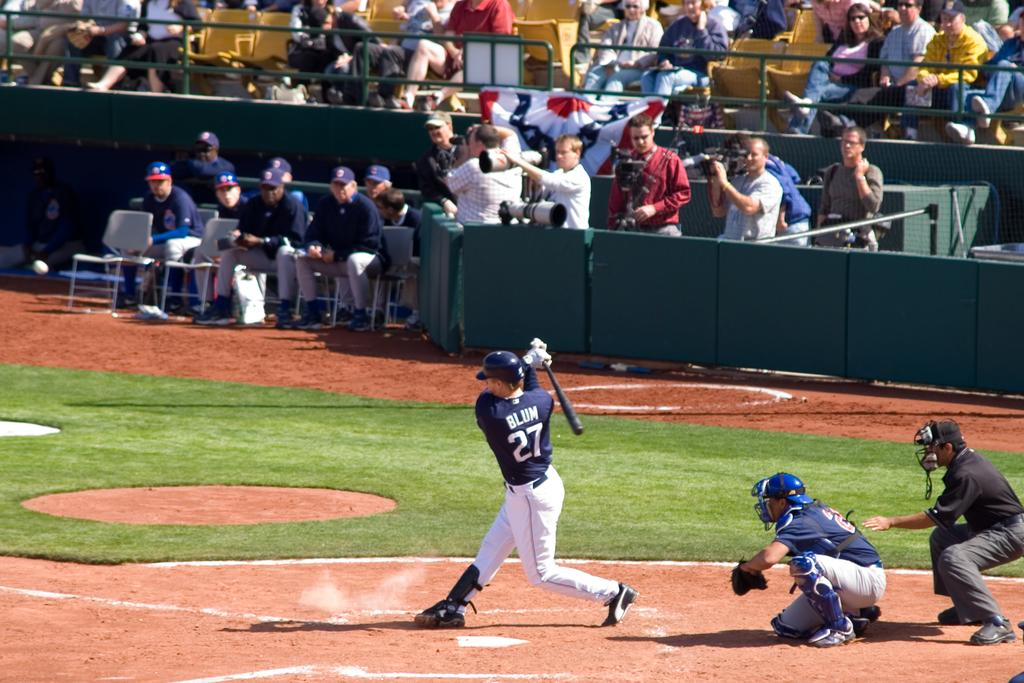Provide a one-sentence caption for the provided image. a baseball player on the field with the number 27. 